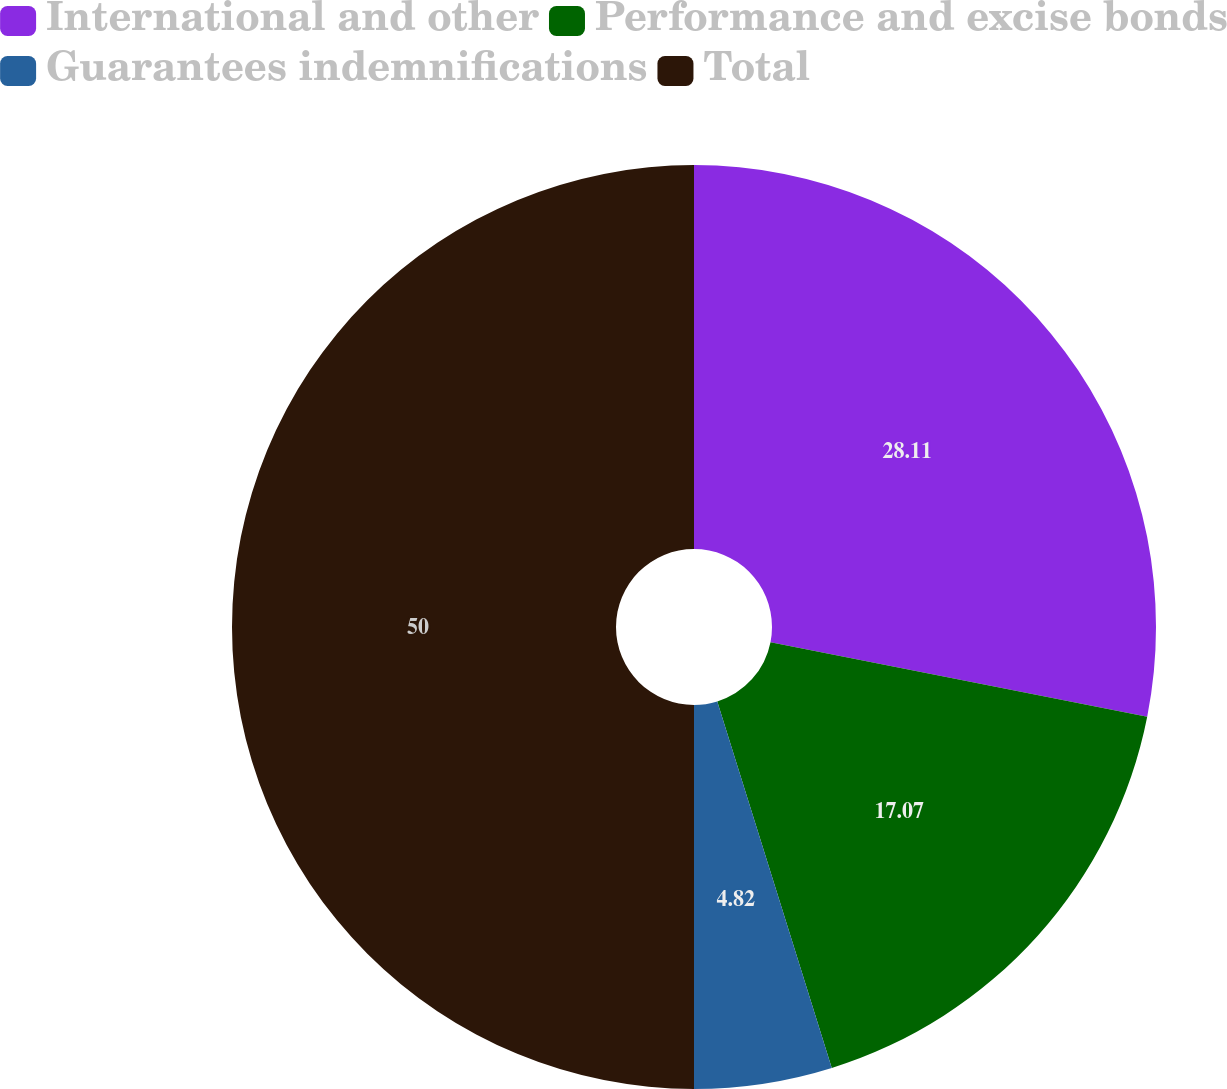Convert chart. <chart><loc_0><loc_0><loc_500><loc_500><pie_chart><fcel>International and other<fcel>Performance and excise bonds<fcel>Guarantees indemnifications<fcel>Total<nl><fcel>28.11%<fcel>17.07%<fcel>4.82%<fcel>50.0%<nl></chart> 